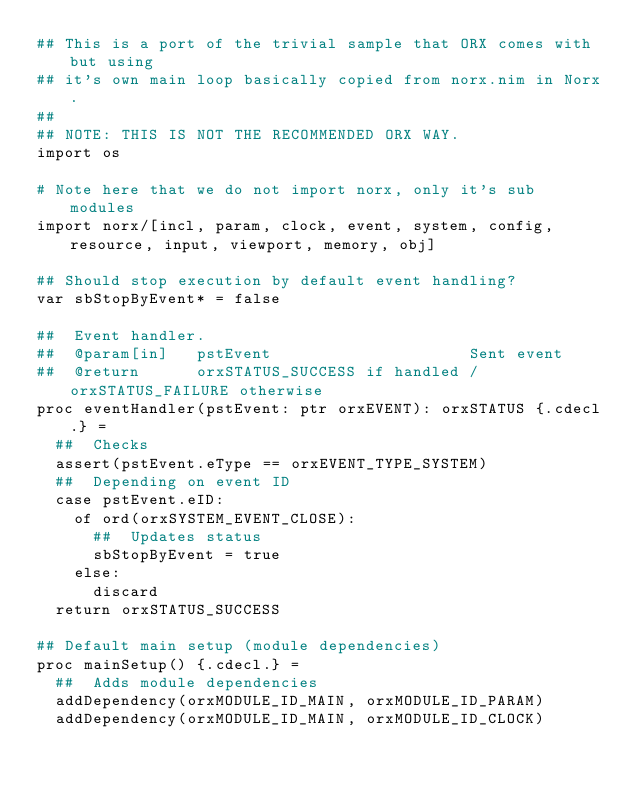<code> <loc_0><loc_0><loc_500><loc_500><_Nim_>## This is a port of the trivial sample that ORX comes with but using
## it's own main loop basically copied from norx.nim in Norx.
##
## NOTE: THIS IS NOT THE RECOMMENDED ORX WAY.
import os

# Note here that we do not import norx, only it's sub modules
import norx/[incl, param, clock, event, system, config, resource, input, viewport, memory, obj]

## Should stop execution by default event handling?
var sbStopByEvent* = false

##  Event handler.
##  @param[in]   pstEvent                     Sent event
##  @return      orxSTATUS_SUCCESS if handled / orxSTATUS_FAILURE otherwise
proc eventHandler(pstEvent: ptr orxEVENT): orxSTATUS {.cdecl.} =
  ##  Checks
  assert(pstEvent.eType == orxEVENT_TYPE_SYSTEM)
  ##  Depending on event ID
  case pstEvent.eID:
    of ord(orxSYSTEM_EVENT_CLOSE):
      ##  Updates status
      sbStopByEvent = true
    else:
      discard
  return orxSTATUS_SUCCESS

## Default main setup (module dependencies)
proc mainSetup() {.cdecl.} =
  ##  Adds module dependencies
  addDependency(orxMODULE_ID_MAIN, orxMODULE_ID_PARAM)
  addDependency(orxMODULE_ID_MAIN, orxMODULE_ID_CLOCK)</code> 